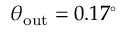Convert formula to latex. <formula><loc_0><loc_0><loc_500><loc_500>\theta _ { o u t } = 0 . 1 7 ^ { \circ }</formula> 